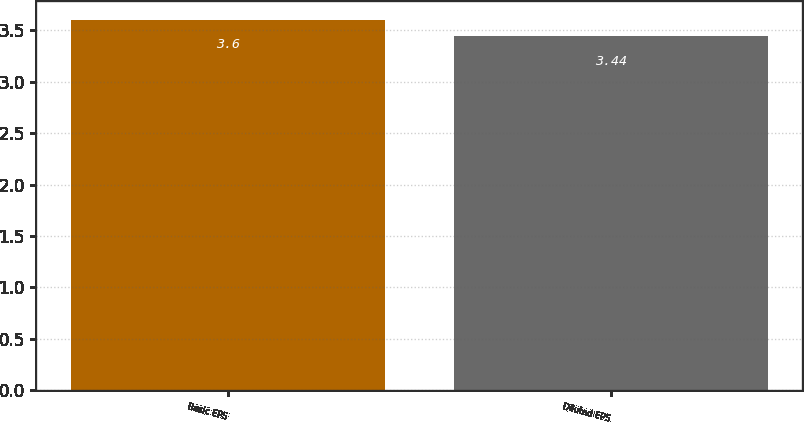Convert chart to OTSL. <chart><loc_0><loc_0><loc_500><loc_500><bar_chart><fcel>Basic EPS<fcel>Diluted EPS<nl><fcel>3.6<fcel>3.44<nl></chart> 